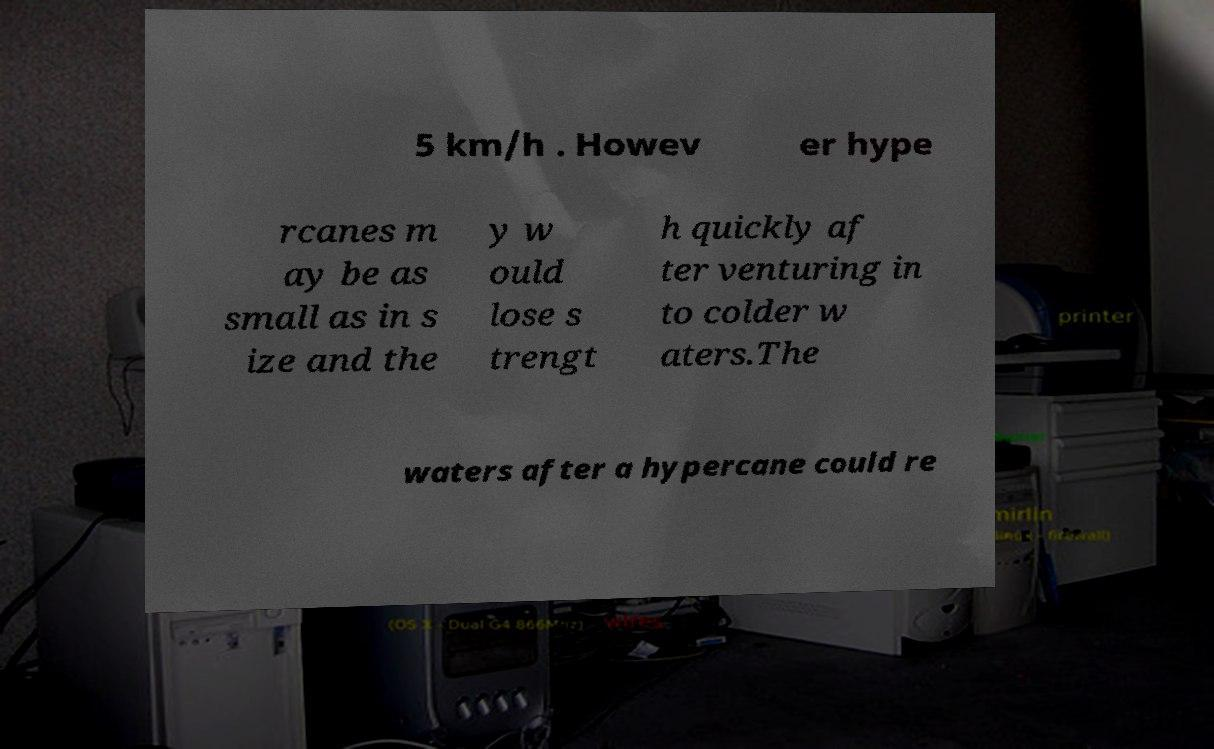Could you assist in decoding the text presented in this image and type it out clearly? 5 km/h . Howev er hype rcanes m ay be as small as in s ize and the y w ould lose s trengt h quickly af ter venturing in to colder w aters.The waters after a hypercane could re 